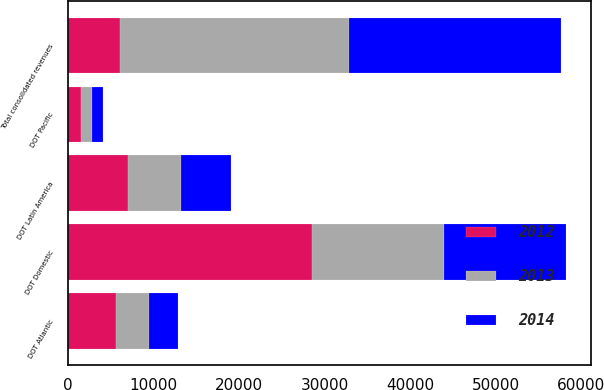Convert chart to OTSL. <chart><loc_0><loc_0><loc_500><loc_500><stacked_bar_chart><ecel><fcel>DOT Domestic<fcel>DOT Latin America<fcel>DOT Atlantic<fcel>DOT Pacific<fcel>Total consolidated revenues<nl><fcel>2012<fcel>28568<fcel>6964<fcel>5652<fcel>1466<fcel>6050.5<nl><fcel>2013<fcel>15376<fcel>6288<fcel>3756<fcel>1323<fcel>26743<nl><fcel>2014<fcel>14287<fcel>5813<fcel>3411<fcel>1344<fcel>24855<nl></chart> 